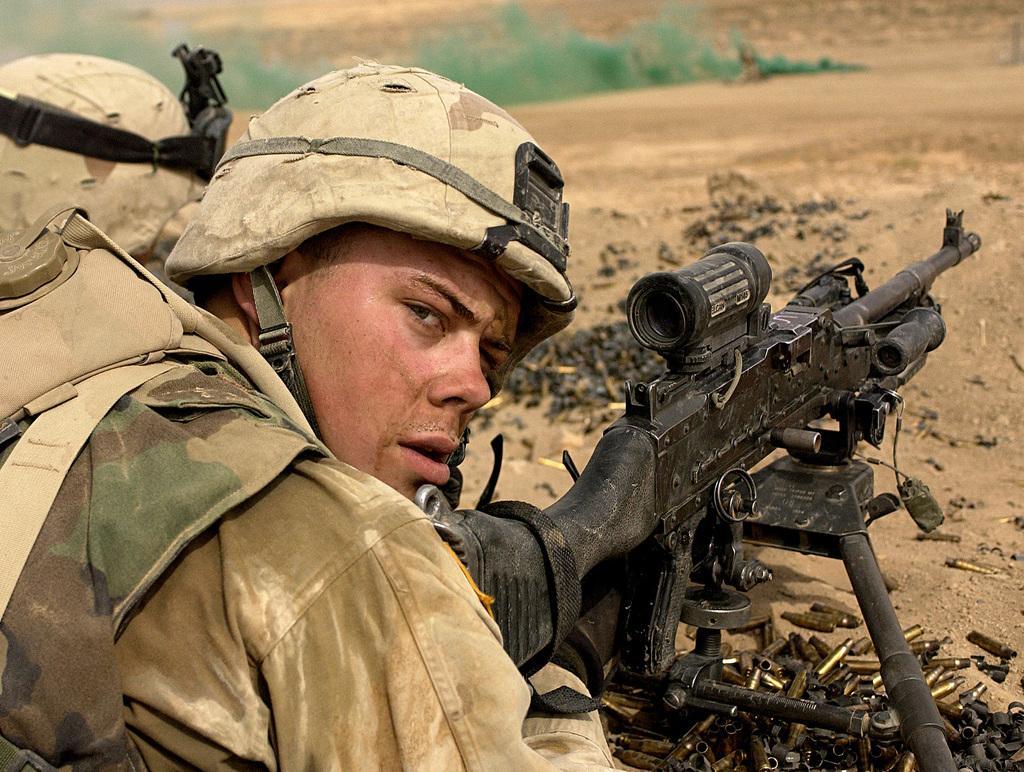Describe this image in one or two sentences. In this image I can see two soldiers. Person on the right hand side is watching the cam, in front of him I can see a gun kept on a metal arrangement I can see number of bullets or bullet caps on the ground. 